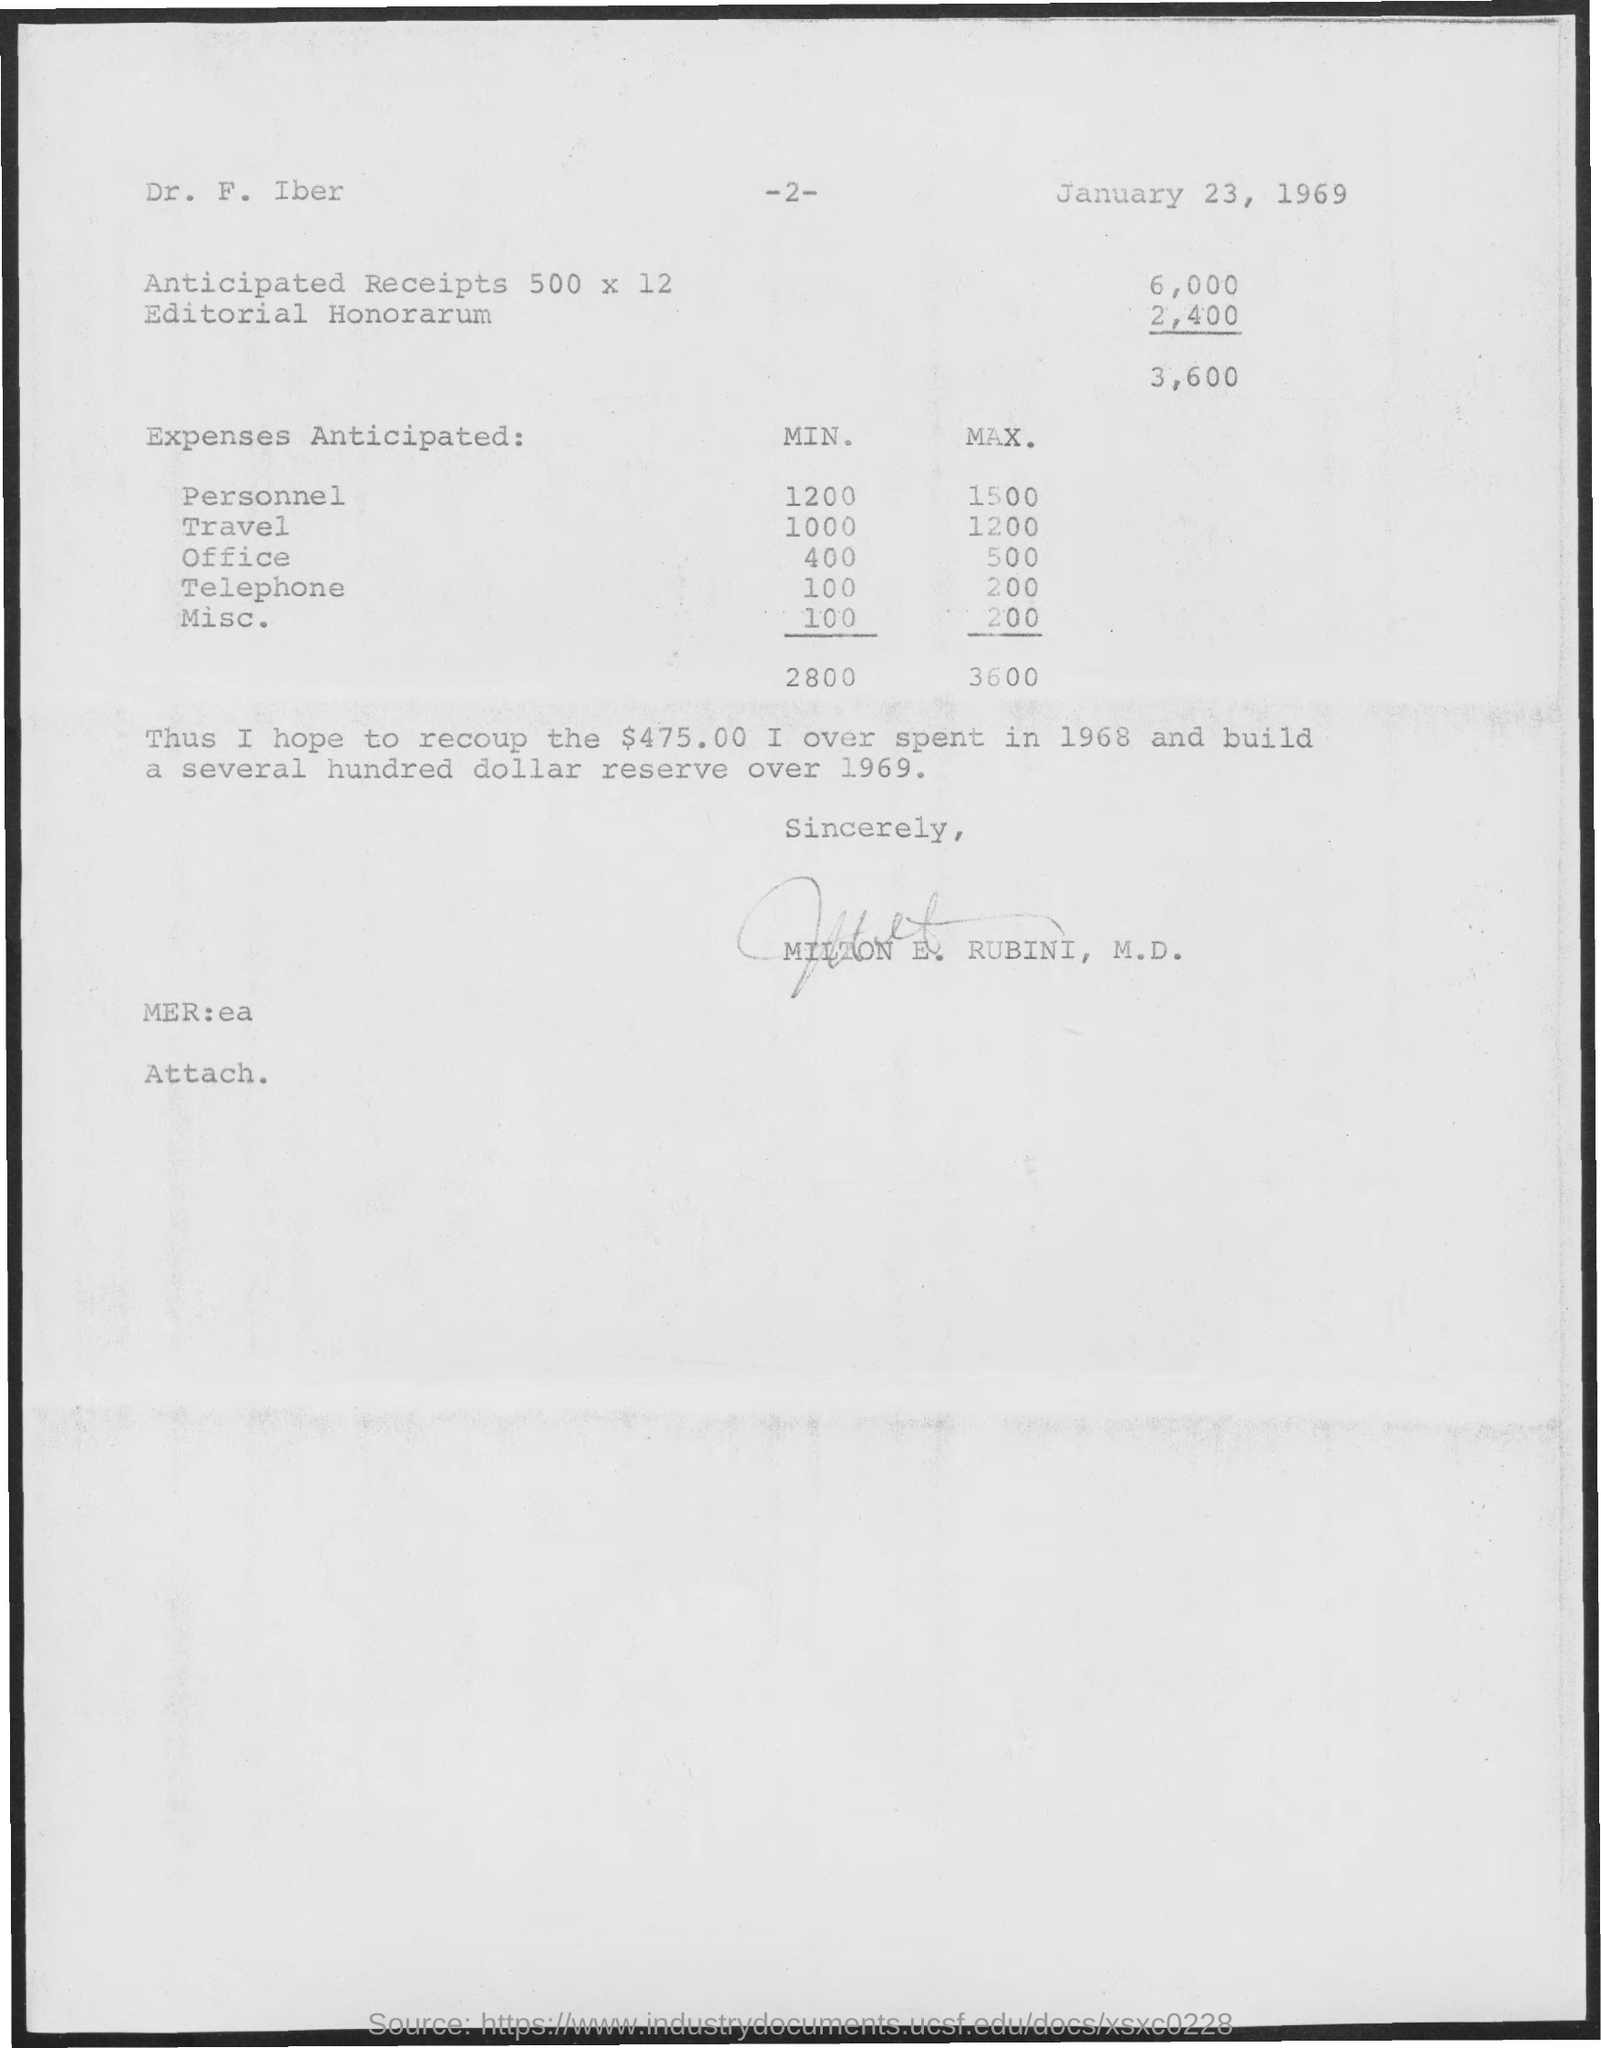Indicate a few pertinent items in this graphic. The maximum anticipated travel expense is 1200. The minimum expected miscellaneous expenses are 100. The declaration states that the document has been signed by Milton E. Rubini, M.D. The minimum personnel expense anticipated is 1200. 